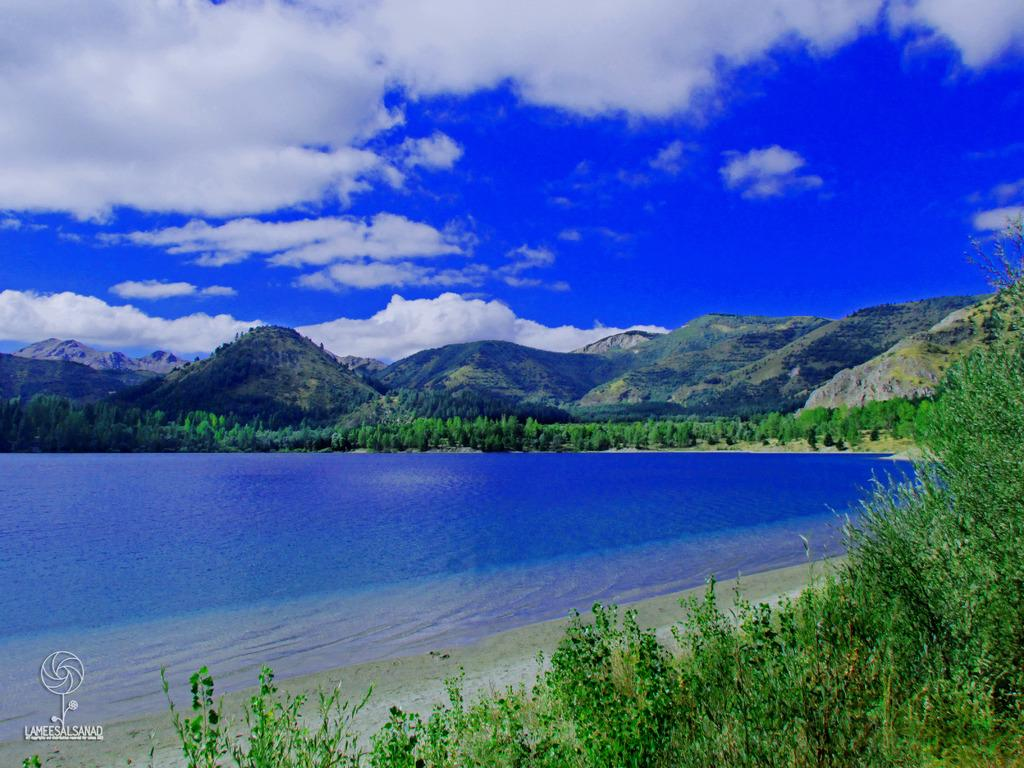What type of landscape can be seen in the image? There are hills in the image. What is the condition of the sky in the image? The sky is cloudy in the image. What natural element is visible in the image? There is water visible in the image. What type of vegetation is present in the image? There are trees in the image. Can you tell me what type of apparel the swing is wearing in the image? There is no swing present in the image, so it is not possible to determine what type of apparel it might be wearing. 